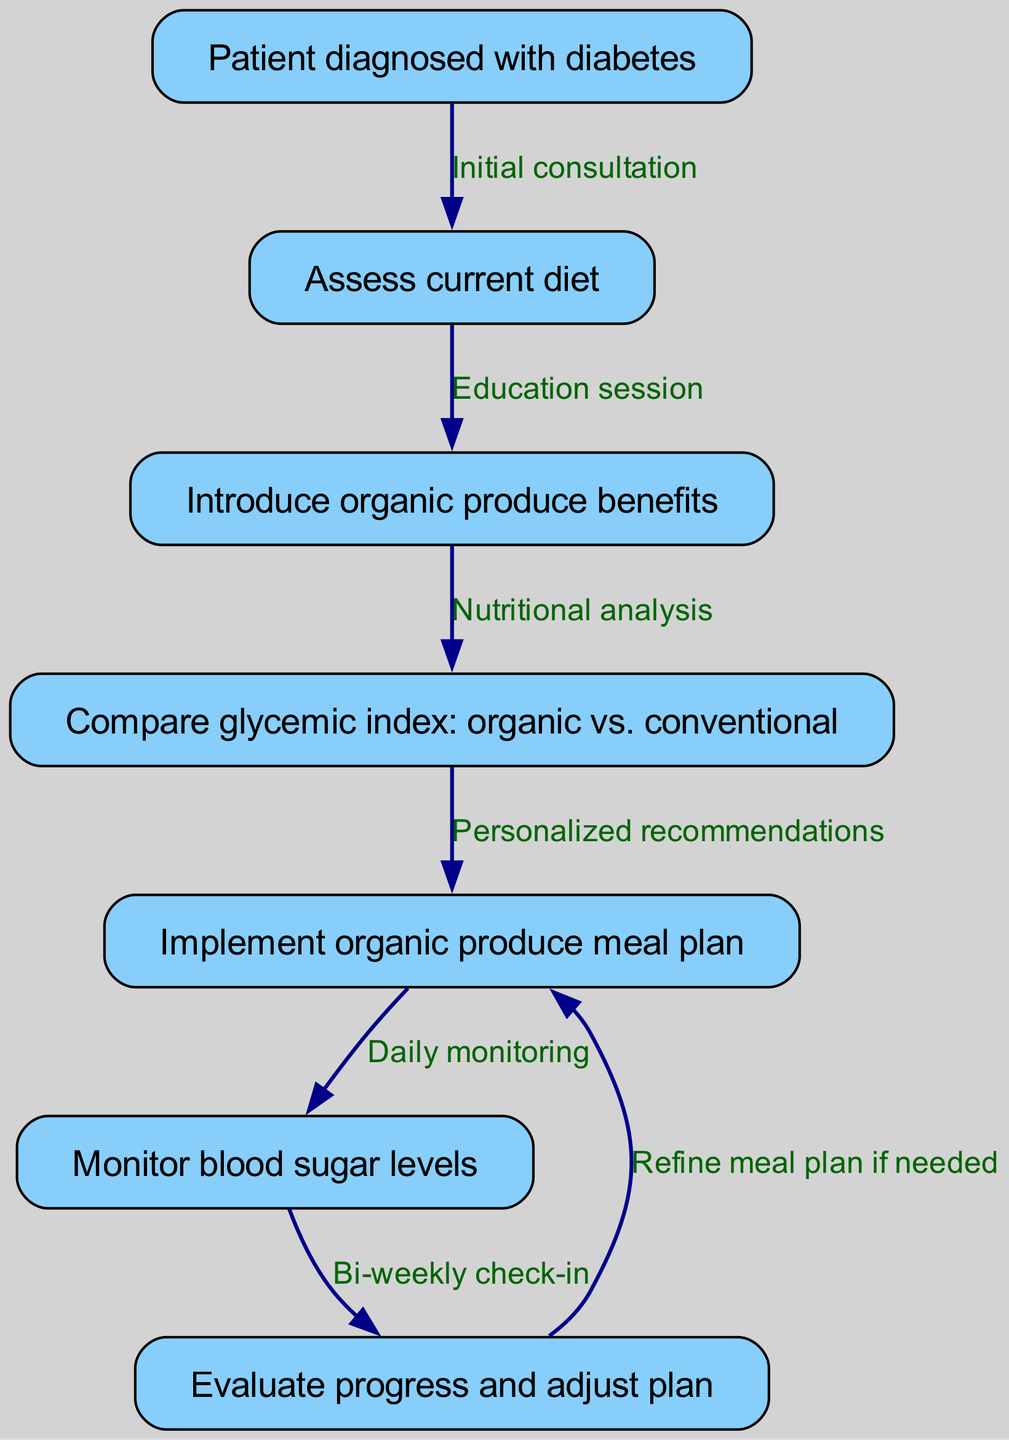What is the initial step for a patient diagnosed with diabetes? The diagram starts with the first node labeled "Patient diagnosed with diabetes," indicating that this is the starting point of the clinical pathway for managing their condition.
Answer: Patient diagnosed with diabetes How many nodes are in the diagram? By counting the nodes listed in the data section, there are a total of seven nodes identified by their steps, indicating various processes in the clinical pathway.
Answer: Seven What is the relationship between "Assess current diet" and "Introduce organic produce benefits"? The diagram shows an edge connecting node 2 ("Assess current diet") and node 3 ("Introduce organic produce benefits") with the label "Education session," indicating that assessing the diet leads to educating the patient.
Answer: Education session Which process comes after implementing the organic produce meal plan? The flow of the diagram indicates that the next step after "Implement organic produce meal plan" (node 5) is "Monitor blood sugar levels" (node 6), creating a subsequent action in the pathway.
Answer: Monitor blood sugar levels What does the edge from "Evaluate progress and adjust plan" lead to? The diagram shows that the edge from "Evaluate progress and adjust plan" (node 7) points back to "Implement organic produce meal plan" (node 5), indicating a cyclic adjustment process based on evaluation.
Answer: Implement organic produce meal plan What are the personalized recommendations based on? The edge labeled "Personalized recommendations" connects "Compare glycemic index: organic vs. conventional" (node 4) to "Implement organic produce meal plan" (node 5), indicating that the recommendations are personalized based on the glycemic index comparison.
Answer: Glycemic index comparison What is monitored during the daily monitoring phase? The "Daily monitoring" phase follows "Implement organic produce meal plan" and is focused on "Monitor blood sugar levels," suggesting that the key aspect of this monitoring is the patient's blood sugar levels.
Answer: Blood sugar levels What type of session follows the initial consultation? The diagram indicates that "Assess current diet" (node 2) comes after "Patient diagnosed with diabetes," and this assessment is part of an "Education session," which is the follow-up activity.
Answer: Education session What occurs at bi-weekly check-ins? The diagram indicates that at "Bi-weekly check-in" (after node 6), the focus is on "Evaluate progress and adjust plan" (node 7), highlighting the purpose of these check-ins as a time to assess the patient’s progress.
Answer: Evaluate progress and adjust plan 